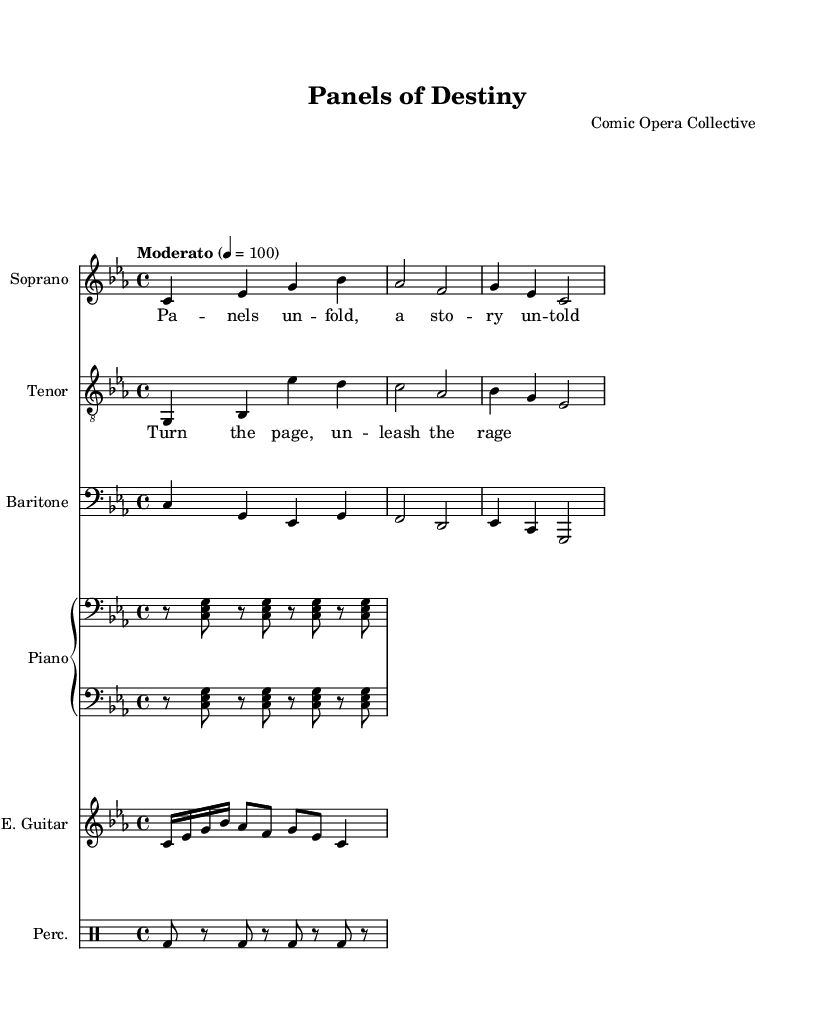What is the key signature of this music? The key signature at the beginning of the score indicates C minor, which has three flats: B flat, E flat, and A flat.
Answer: C minor What is the time signature of this piece? The time signature is indicated by the fraction at the start of the score, which shows 4 beats per measure, with a quarter note receiving one beat.
Answer: 4/4 What is the tempo marking of this opera? The tempo is marked at the beginning with "Moderato," which typically means moderately brisk.
Answer: Moderato How many voices are included in this composition? By counting the distinct staff sections in the score that represent vocal parts, we identify three voices: soprano, tenor, and baritone.
Answer: Three Which instrument appears alongside the vocal parts? The score specifies additional instruments, and in this case, we see a piano staff added, which supports the vocal lines.
Answer: Piano What is the theme expressed in the lyrics of the verse? The lyrics provided express a theme of unfolding stories and mysteries, as suggested by the phrase "Panels unfold, a story untold."
Answer: Unfolding stories How does the experimental nature of this opera relate to comic book elements? The opera incorporates visuals and layout styles similar to comic books, suggesting a narrative flow and visual storytelling akin to comic panel designs.
Answer: Multimedia storytelling 